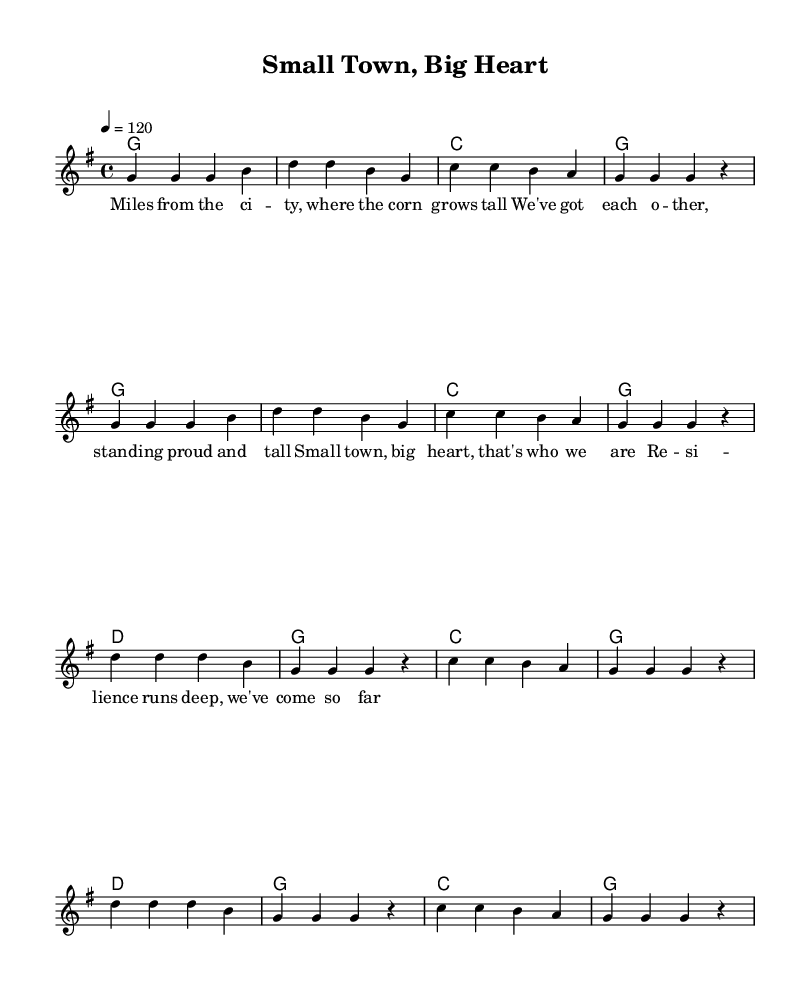What is the key signature of this music? The key signature is G major, which has one sharp (F#). This is determined by the presence of the key signature indicated at the beginning of the score.
Answer: G major What is the time signature of this music? The time signature is 4/4, which means there are four beats in each measure and a quarter note gets one beat. This is indicated at the beginning of the score next to the key signature.
Answer: 4/4 What is the tempo marking for this piece? The tempo marking is quarter note equals 120. This shows that the piece should be played at a speed of 120 beats per minute, indicated at the beginning of the score.
Answer: 120 How many measures are in the verse of this song? The verse consists of four measures. By counting the vertical lines (bar lines) separating the notes in the verse section, we find a total of four.
Answer: Four What is the overall theme expressed in the chorus? The overall theme in the chorus is resilience. The lyrics reiterate the strength and endurance of the rural community, celebrating their perseverance in the face of challenges.
Answer: Resilience How does the harmony change in the chorus compared to the verse? In the chorus, the harmony shifts to include the D major chord alongside the G and C chords, enhancing the support for the melody. The verse predominantly features just G and C.
Answer: Added D major chord What is the lyrical content of the first line of the verse? The first line of the verse is "Miles from the city, where the corn grows tall." This is directly found in the lyrics section, denoting the geographical and personal connection to rural life.
Answer: Miles from the city, where the corn grows tall 